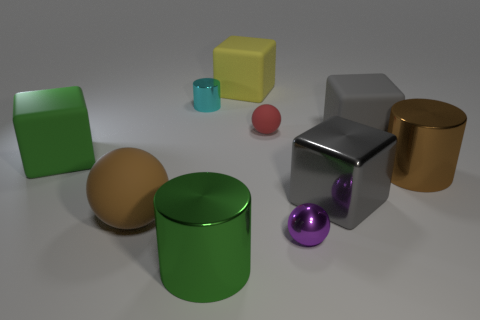Is there a large cube that is right of the large metal thing that is left of the small red rubber object?
Your answer should be compact. Yes. What is the color of the metal cylinder behind the gray rubber block?
Ensure brevity in your answer.  Cyan. Is the number of big gray things in front of the large brown shiny cylinder the same as the number of brown metallic cylinders?
Make the answer very short. Yes. The object that is in front of the large metal cube and to the right of the small red rubber object has what shape?
Offer a terse response. Sphere. There is a shiny thing that is the same shape as the green rubber thing; what is its color?
Give a very brief answer. Gray. Is there anything else that has the same color as the shiny ball?
Provide a short and direct response. No. The brown object that is right of the large gray block that is behind the rubber cube on the left side of the big green cylinder is what shape?
Make the answer very short. Cylinder. There is a shiny cylinder that is to the right of the purple thing; does it have the same size as the green object behind the large brown shiny cylinder?
Ensure brevity in your answer.  Yes. How many other cylinders have the same material as the green cylinder?
Make the answer very short. 2. There is a big matte cube left of the large green metal cylinder that is in front of the brown cylinder; what number of tiny red objects are on the left side of it?
Your response must be concise. 0. 